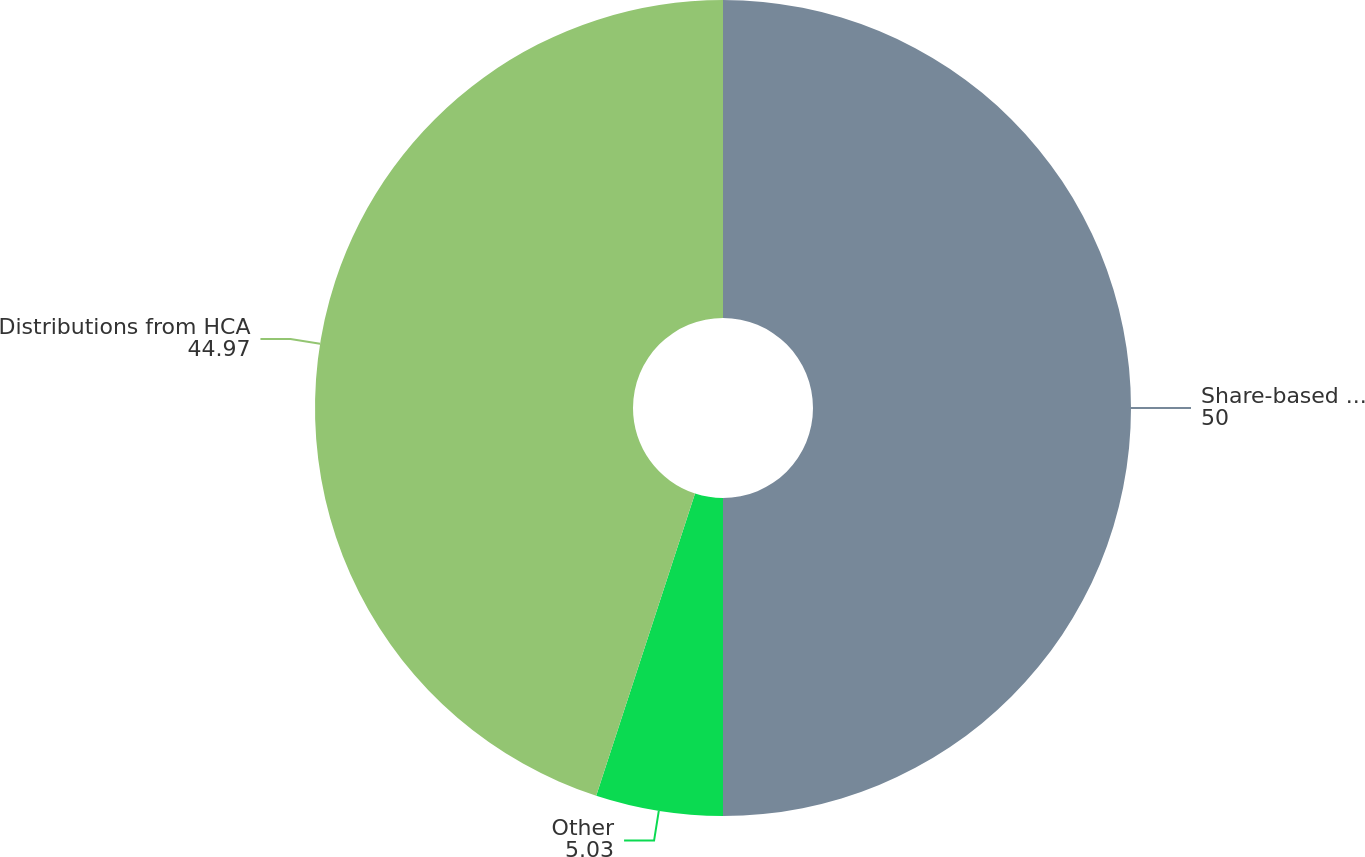Convert chart. <chart><loc_0><loc_0><loc_500><loc_500><pie_chart><fcel>Share-based benefit plans<fcel>Other<fcel>Distributions from HCA<nl><fcel>50.0%<fcel>5.03%<fcel>44.97%<nl></chart> 